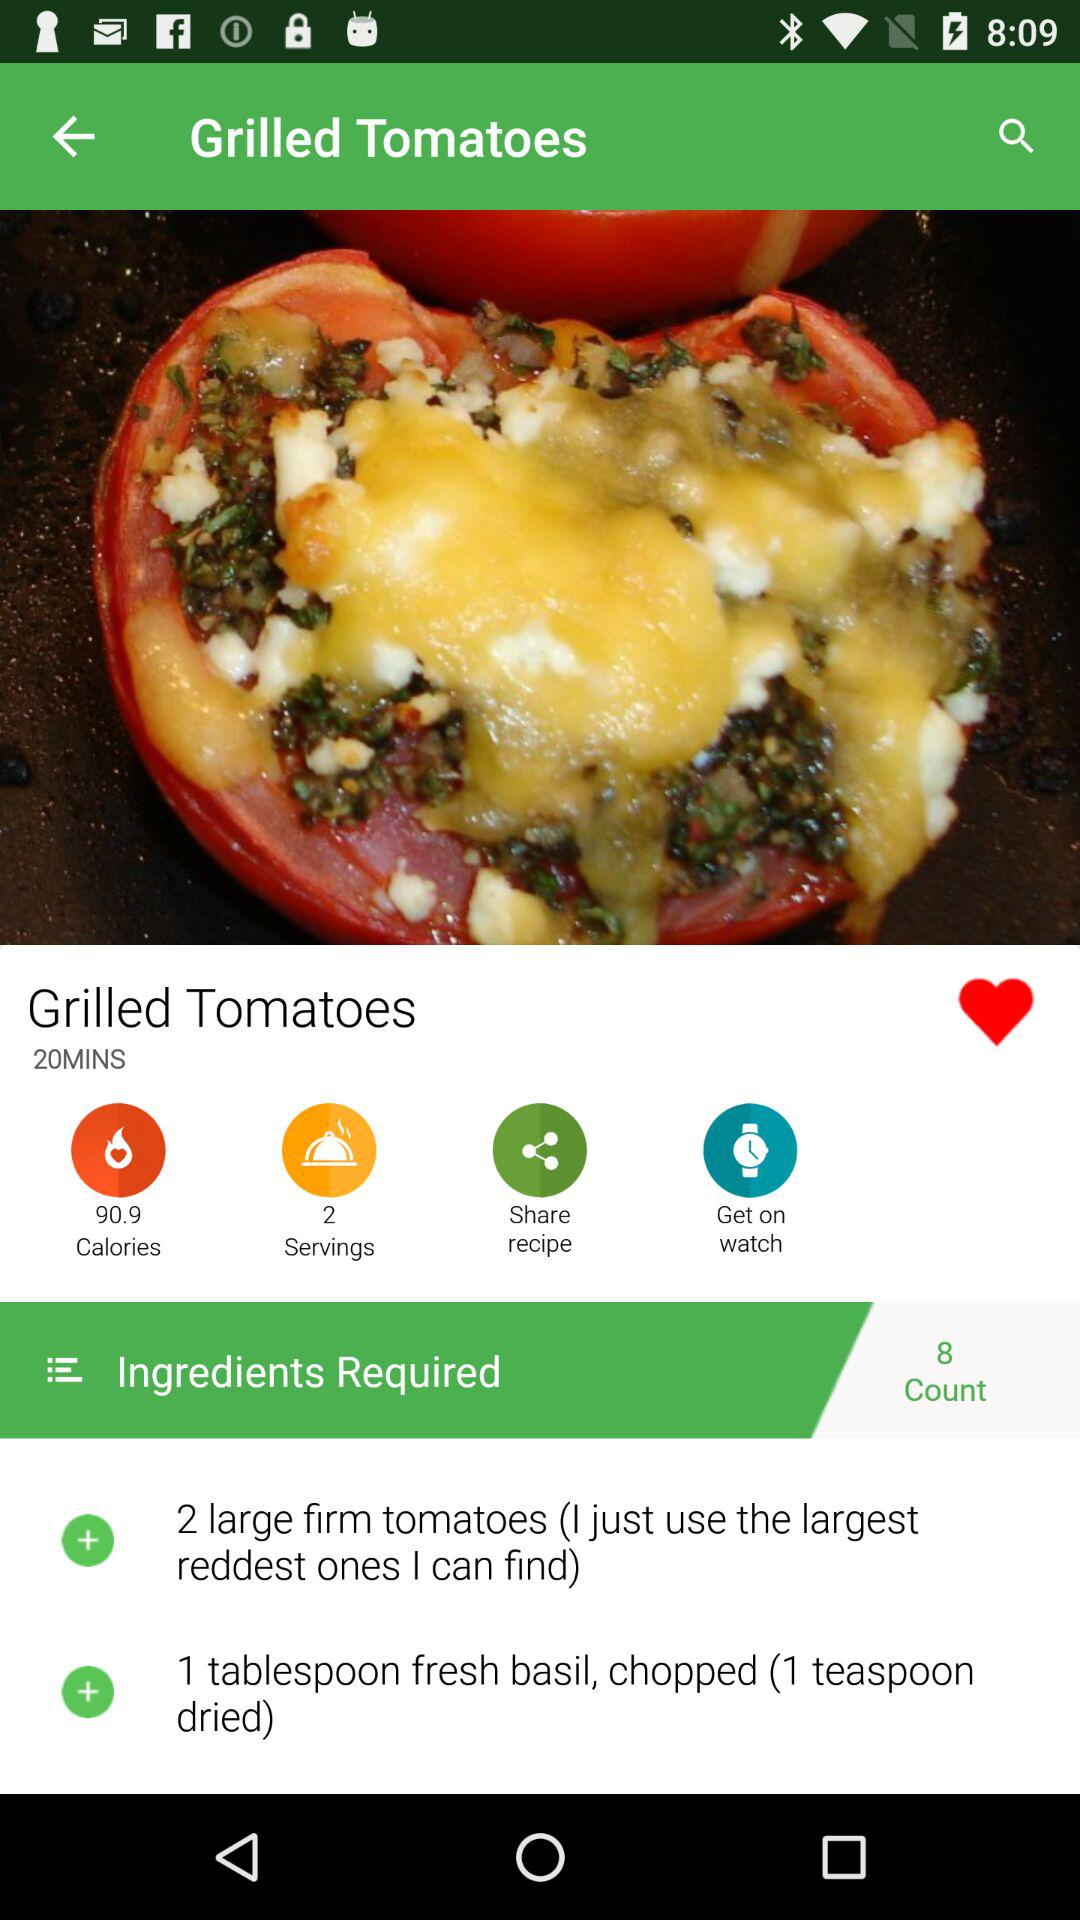How many ingredients are required? There are 8 ingredients required. 